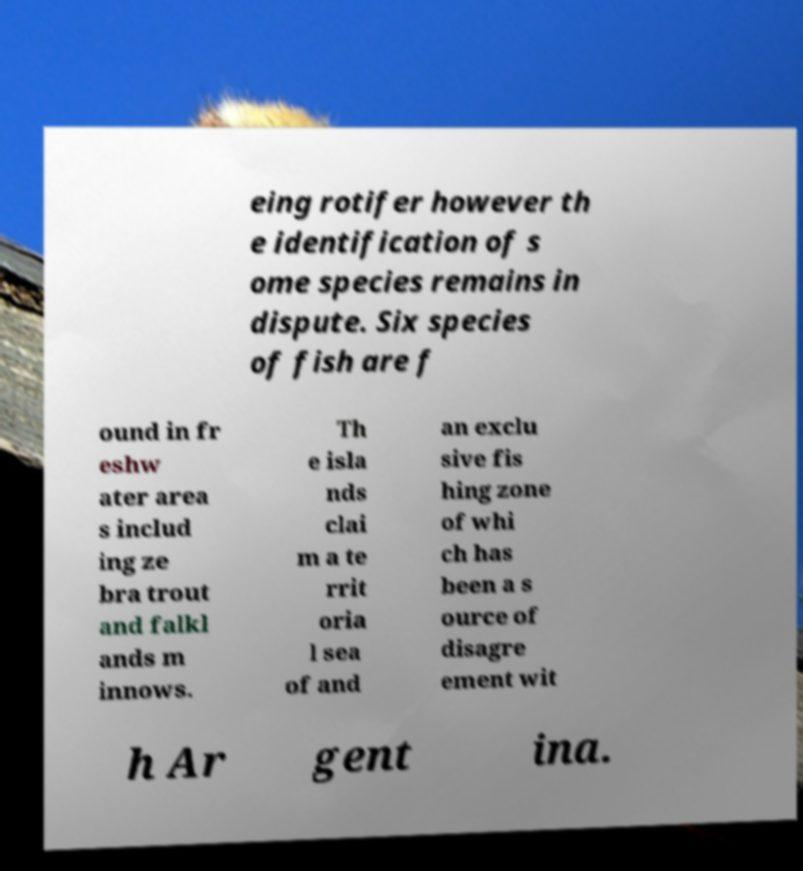Could you extract and type out the text from this image? eing rotifer however th e identification of s ome species remains in dispute. Six species of fish are f ound in fr eshw ater area s includ ing ze bra trout and falkl ands m innows. Th e isla nds clai m a te rrit oria l sea of and an exclu sive fis hing zone of whi ch has been a s ource of disagre ement wit h Ar gent ina. 